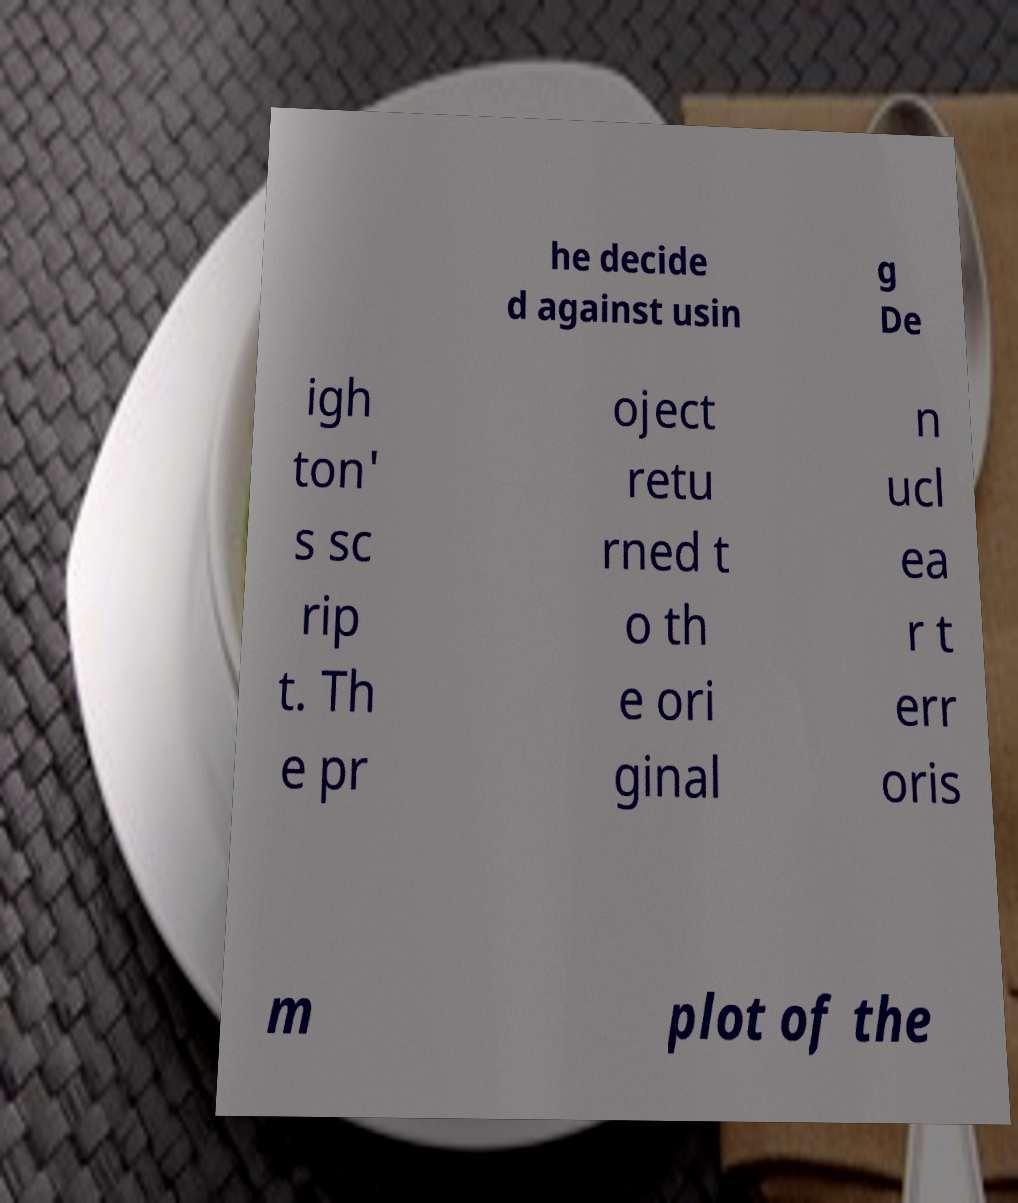What messages or text are displayed in this image? I need them in a readable, typed format. he decide d against usin g De igh ton' s sc rip t. Th e pr oject retu rned t o th e ori ginal n ucl ea r t err oris m plot of the 